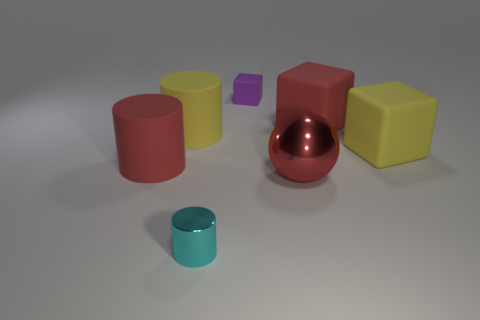Add 2 yellow blocks. How many objects exist? 9 Subtract all tiny cylinders. How many cylinders are left? 2 Subtract all purple cubes. How many cubes are left? 2 Subtract all cyan cylinders. How many brown cubes are left? 0 Subtract 2 blocks. How many blocks are left? 1 Subtract all big red shiny spheres. Subtract all big matte cubes. How many objects are left? 4 Add 3 red rubber cubes. How many red rubber cubes are left? 4 Add 5 large red rubber balls. How many large red rubber balls exist? 5 Subtract 0 purple balls. How many objects are left? 7 Subtract all spheres. How many objects are left? 6 